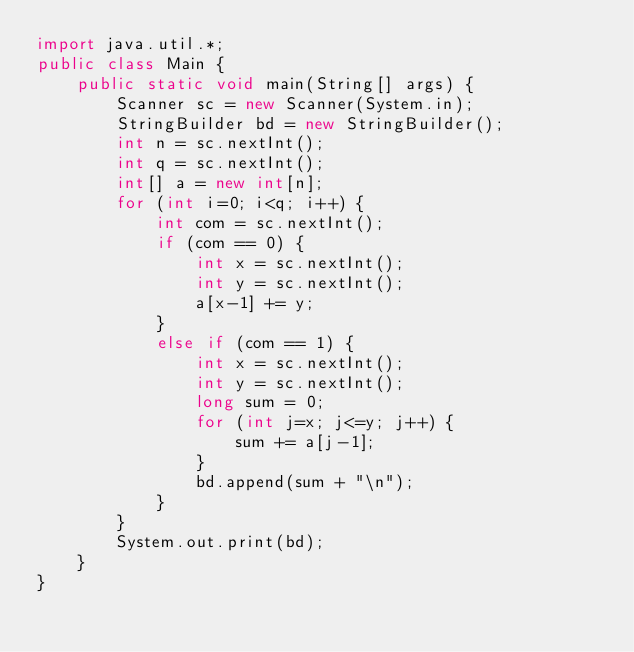Convert code to text. <code><loc_0><loc_0><loc_500><loc_500><_Java_>import java.util.*;
public class Main {
    public static void main(String[] args) {
        Scanner sc = new Scanner(System.in);
        StringBuilder bd = new StringBuilder();
        int n = sc.nextInt();
        int q = sc.nextInt();
        int[] a = new int[n];
        for (int i=0; i<q; i++) {
            int com = sc.nextInt();
            if (com == 0) {
                int x = sc.nextInt();
                int y = sc.nextInt();
                a[x-1] += y;
            }
            else if (com == 1) {
                int x = sc.nextInt();
                int y = sc.nextInt();
                long sum = 0;
                for (int j=x; j<=y; j++) {
                    sum += a[j-1];
                }
                bd.append(sum + "\n");
            }
        }
        System.out.print(bd);
    }
}
</code> 